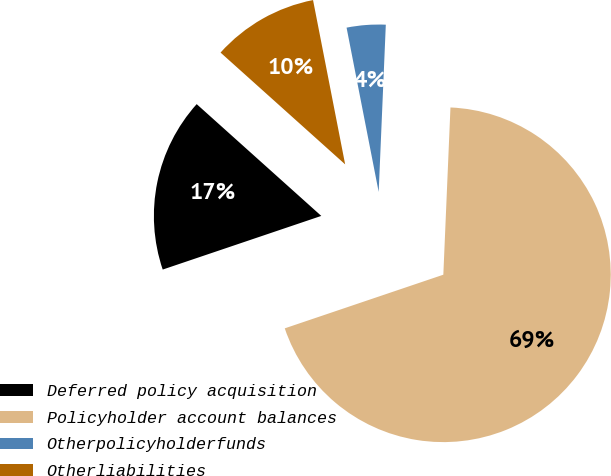<chart> <loc_0><loc_0><loc_500><loc_500><pie_chart><fcel>Deferred policy acquisition<fcel>Policyholder account balances<fcel>Otherpolicyholderfunds<fcel>Otherliabilities<nl><fcel>16.83%<fcel>69.13%<fcel>3.75%<fcel>10.29%<nl></chart> 